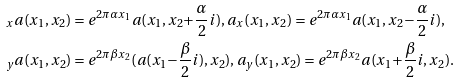Convert formula to latex. <formula><loc_0><loc_0><loc_500><loc_500>& { _ { x } a } ( x _ { 1 } , x _ { 2 } ) = e ^ { 2 \pi \alpha x _ { 1 } } a ( x _ { 1 } , x _ { 2 } { + } { \frac { \alpha } { 2 } } i ) , a _ { x } ( x _ { 1 } , x _ { 2 } ) = e ^ { 2 \pi \alpha x _ { 1 } } a ( x _ { 1 } , x _ { 2 } { - } { \frac { \alpha } { 2 } } i ) , \\ & { _ { y } a } ( x _ { 1 } , x _ { 2 } ) = e ^ { 2 \pi \beta x _ { 2 } } ( a ( x _ { 1 } { - } { \frac { \beta } { 2 } } i ) , x _ { 2 } ) , a _ { y } ( x _ { 1 } , x _ { 2 } ) = e ^ { 2 \pi \beta x _ { 2 } } a ( x _ { 1 } { + } { \frac { \beta } { 2 } } i , x _ { 2 } ) .</formula> 